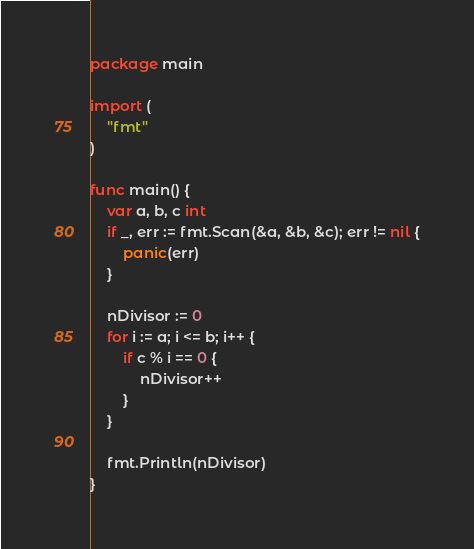<code> <loc_0><loc_0><loc_500><loc_500><_Go_>package main

import (
	"fmt"
)

func main() {
	var a, b, c int
	if _, err := fmt.Scan(&a, &b, &c); err != nil {
		panic(err)
	}

	nDivisor := 0
	for i := a; i <= b; i++ {
		if c % i == 0 {
			nDivisor++
		}
	}

	fmt.Println(nDivisor)
}

</code> 